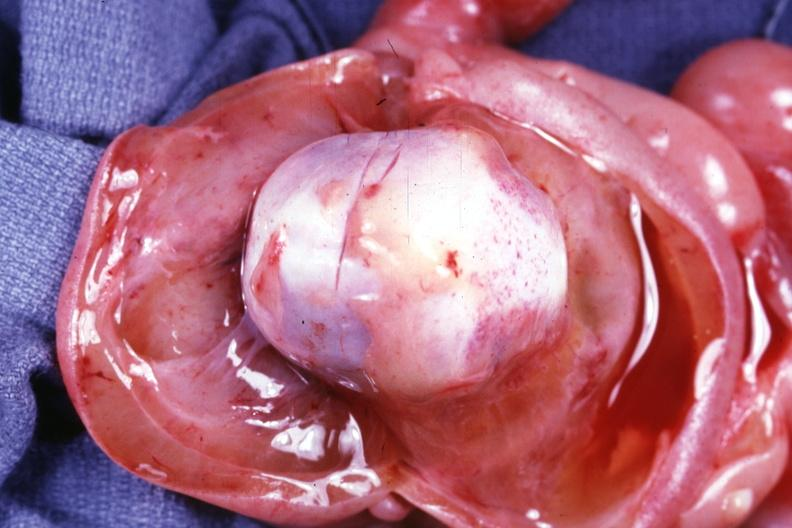does this image show opened scalp to show small cranium inside of boggy edematous scalp?
Answer the question using a single word or phrase. Yes 